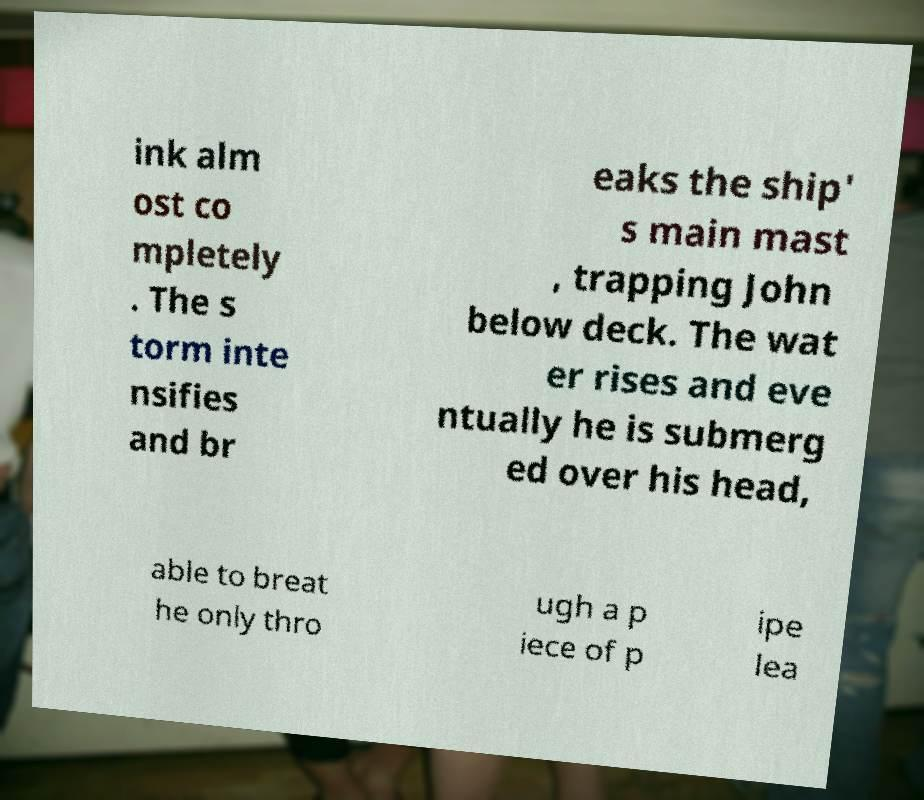For documentation purposes, I need the text within this image transcribed. Could you provide that? ink alm ost co mpletely . The s torm inte nsifies and br eaks the ship' s main mast , trapping John below deck. The wat er rises and eve ntually he is submerg ed over his head, able to breat he only thro ugh a p iece of p ipe lea 